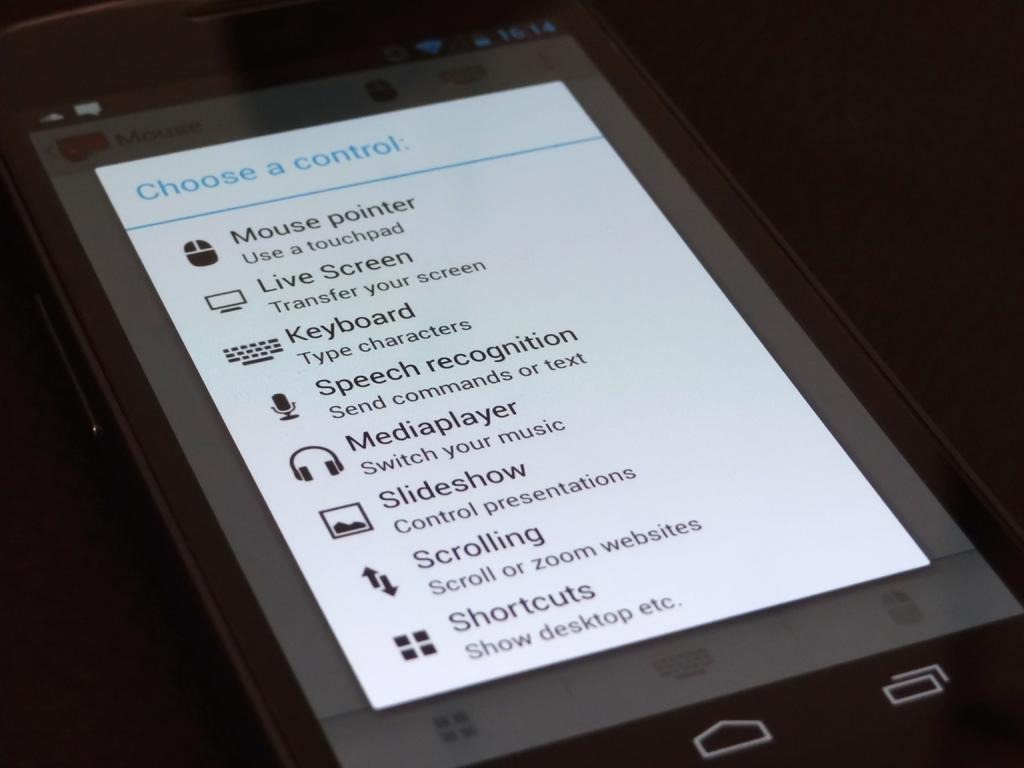<image>
Share a concise interpretation of the image provided. An ipad that shows the settings for the device to access the keyboard, speech recognition, Media player and other features 